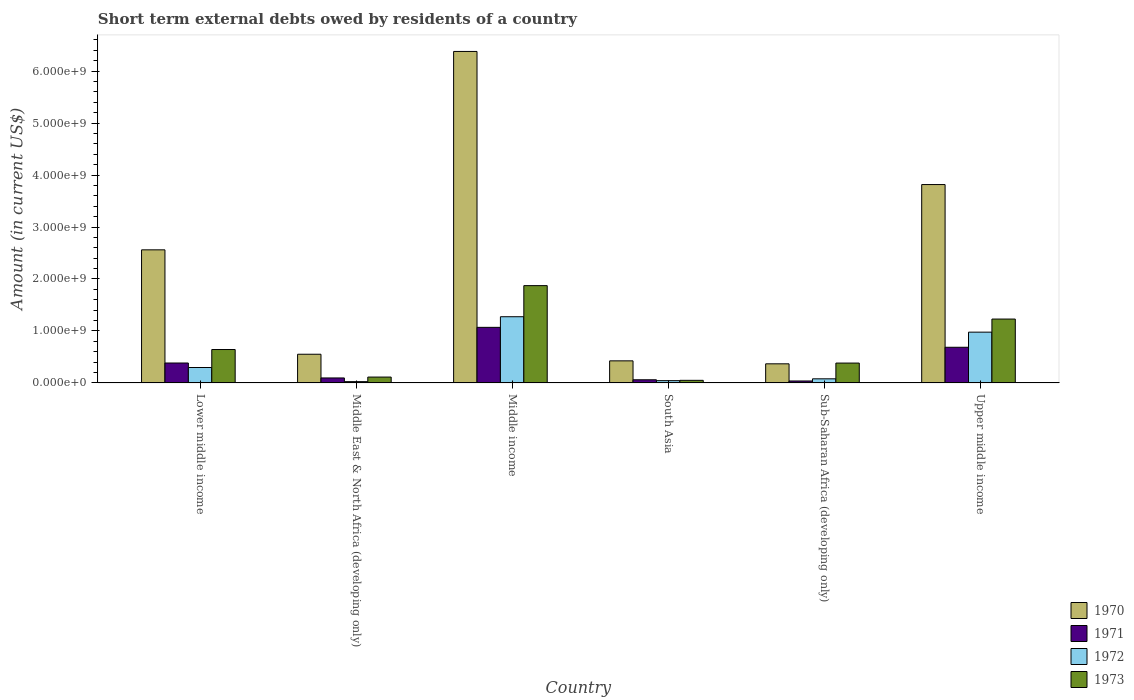How many groups of bars are there?
Your answer should be compact. 6. Are the number of bars per tick equal to the number of legend labels?
Offer a very short reply. Yes. Are the number of bars on each tick of the X-axis equal?
Make the answer very short. Yes. How many bars are there on the 5th tick from the left?
Make the answer very short. 4. What is the label of the 1st group of bars from the left?
Offer a terse response. Lower middle income. In how many cases, is the number of bars for a given country not equal to the number of legend labels?
Your response must be concise. 0. What is the amount of short-term external debts owed by residents in 1973 in Upper middle income?
Your answer should be compact. 1.23e+09. Across all countries, what is the maximum amount of short-term external debts owed by residents in 1970?
Offer a terse response. 6.38e+09. Across all countries, what is the minimum amount of short-term external debts owed by residents in 1970?
Give a very brief answer. 3.68e+08. In which country was the amount of short-term external debts owed by residents in 1973 maximum?
Provide a short and direct response. Middle income. What is the total amount of short-term external debts owed by residents in 1972 in the graph?
Provide a succinct answer. 2.70e+09. What is the difference between the amount of short-term external debts owed by residents in 1971 in Lower middle income and that in Upper middle income?
Ensure brevity in your answer.  -3.03e+08. What is the difference between the amount of short-term external debts owed by residents in 1972 in Middle income and the amount of short-term external debts owed by residents in 1973 in Upper middle income?
Ensure brevity in your answer.  4.48e+07. What is the average amount of short-term external debts owed by residents in 1970 per country?
Provide a succinct answer. 2.35e+09. What is the difference between the amount of short-term external debts owed by residents of/in 1973 and amount of short-term external debts owed by residents of/in 1971 in South Asia?
Your response must be concise. -1.10e+07. What is the ratio of the amount of short-term external debts owed by residents in 1970 in South Asia to that in Sub-Saharan Africa (developing only)?
Ensure brevity in your answer.  1.16. Is the amount of short-term external debts owed by residents in 1972 in Middle income less than that in Upper middle income?
Your answer should be very brief. No. Is the difference between the amount of short-term external debts owed by residents in 1973 in Lower middle income and Upper middle income greater than the difference between the amount of short-term external debts owed by residents in 1971 in Lower middle income and Upper middle income?
Give a very brief answer. No. What is the difference between the highest and the second highest amount of short-term external debts owed by residents in 1972?
Make the answer very short. 2.97e+08. What is the difference between the highest and the lowest amount of short-term external debts owed by residents in 1973?
Offer a terse response. 1.82e+09. In how many countries, is the amount of short-term external debts owed by residents in 1973 greater than the average amount of short-term external debts owed by residents in 1973 taken over all countries?
Provide a succinct answer. 2. Is the sum of the amount of short-term external debts owed by residents in 1971 in South Asia and Upper middle income greater than the maximum amount of short-term external debts owed by residents in 1970 across all countries?
Provide a short and direct response. No. Is it the case that in every country, the sum of the amount of short-term external debts owed by residents in 1972 and amount of short-term external debts owed by residents in 1971 is greater than the sum of amount of short-term external debts owed by residents in 1970 and amount of short-term external debts owed by residents in 1973?
Keep it short and to the point. No. What does the 2nd bar from the left in Middle East & North Africa (developing only) represents?
Your response must be concise. 1971. Is it the case that in every country, the sum of the amount of short-term external debts owed by residents in 1970 and amount of short-term external debts owed by residents in 1971 is greater than the amount of short-term external debts owed by residents in 1973?
Make the answer very short. Yes. Are all the bars in the graph horizontal?
Provide a short and direct response. No. How many countries are there in the graph?
Make the answer very short. 6. Are the values on the major ticks of Y-axis written in scientific E-notation?
Make the answer very short. Yes. Does the graph contain grids?
Offer a terse response. No. Where does the legend appear in the graph?
Keep it short and to the point. Bottom right. What is the title of the graph?
Keep it short and to the point. Short term external debts owed by residents of a country. Does "2015" appear as one of the legend labels in the graph?
Provide a short and direct response. No. What is the Amount (in current US$) in 1970 in Lower middle income?
Make the answer very short. 2.56e+09. What is the Amount (in current US$) in 1971 in Lower middle income?
Provide a succinct answer. 3.83e+08. What is the Amount (in current US$) in 1972 in Lower middle income?
Your response must be concise. 2.97e+08. What is the Amount (in current US$) in 1973 in Lower middle income?
Keep it short and to the point. 6.43e+08. What is the Amount (in current US$) of 1970 in Middle East & North Africa (developing only)?
Ensure brevity in your answer.  5.52e+08. What is the Amount (in current US$) in 1971 in Middle East & North Africa (developing only)?
Your response must be concise. 9.60e+07. What is the Amount (in current US$) in 1972 in Middle East & North Africa (developing only)?
Your answer should be very brief. 2.50e+07. What is the Amount (in current US$) of 1973 in Middle East & North Africa (developing only)?
Offer a very short reply. 1.13e+08. What is the Amount (in current US$) in 1970 in Middle income?
Provide a succinct answer. 6.38e+09. What is the Amount (in current US$) in 1971 in Middle income?
Provide a short and direct response. 1.07e+09. What is the Amount (in current US$) of 1972 in Middle income?
Ensure brevity in your answer.  1.27e+09. What is the Amount (in current US$) in 1973 in Middle income?
Ensure brevity in your answer.  1.87e+09. What is the Amount (in current US$) of 1970 in South Asia?
Ensure brevity in your answer.  4.25e+08. What is the Amount (in current US$) in 1971 in South Asia?
Your answer should be compact. 6.10e+07. What is the Amount (in current US$) in 1972 in South Asia?
Provide a short and direct response. 4.40e+07. What is the Amount (in current US$) in 1970 in Sub-Saharan Africa (developing only)?
Offer a very short reply. 3.68e+08. What is the Amount (in current US$) of 1971 in Sub-Saharan Africa (developing only)?
Keep it short and to the point. 3.78e+07. What is the Amount (in current US$) of 1972 in Sub-Saharan Africa (developing only)?
Provide a succinct answer. 7.93e+07. What is the Amount (in current US$) in 1973 in Sub-Saharan Africa (developing only)?
Offer a very short reply. 3.82e+08. What is the Amount (in current US$) of 1970 in Upper middle income?
Your answer should be very brief. 3.82e+09. What is the Amount (in current US$) of 1971 in Upper middle income?
Offer a terse response. 6.86e+08. What is the Amount (in current US$) of 1972 in Upper middle income?
Provide a short and direct response. 9.77e+08. What is the Amount (in current US$) of 1973 in Upper middle income?
Give a very brief answer. 1.23e+09. Across all countries, what is the maximum Amount (in current US$) in 1970?
Your response must be concise. 6.38e+09. Across all countries, what is the maximum Amount (in current US$) in 1971?
Keep it short and to the point. 1.07e+09. Across all countries, what is the maximum Amount (in current US$) of 1972?
Offer a very short reply. 1.27e+09. Across all countries, what is the maximum Amount (in current US$) in 1973?
Your response must be concise. 1.87e+09. Across all countries, what is the minimum Amount (in current US$) in 1970?
Offer a very short reply. 3.68e+08. Across all countries, what is the minimum Amount (in current US$) in 1971?
Your response must be concise. 3.78e+07. Across all countries, what is the minimum Amount (in current US$) in 1972?
Give a very brief answer. 2.50e+07. Across all countries, what is the minimum Amount (in current US$) in 1973?
Provide a succinct answer. 5.00e+07. What is the total Amount (in current US$) in 1970 in the graph?
Offer a terse response. 1.41e+1. What is the total Amount (in current US$) of 1971 in the graph?
Offer a very short reply. 2.33e+09. What is the total Amount (in current US$) of 1972 in the graph?
Provide a short and direct response. 2.70e+09. What is the total Amount (in current US$) in 1973 in the graph?
Make the answer very short. 4.29e+09. What is the difference between the Amount (in current US$) of 1970 in Lower middle income and that in Middle East & North Africa (developing only)?
Offer a terse response. 2.01e+09. What is the difference between the Amount (in current US$) in 1971 in Lower middle income and that in Middle East & North Africa (developing only)?
Offer a terse response. 2.87e+08. What is the difference between the Amount (in current US$) in 1972 in Lower middle income and that in Middle East & North Africa (developing only)?
Keep it short and to the point. 2.72e+08. What is the difference between the Amount (in current US$) in 1973 in Lower middle income and that in Middle East & North Africa (developing only)?
Offer a terse response. 5.30e+08. What is the difference between the Amount (in current US$) of 1970 in Lower middle income and that in Middle income?
Ensure brevity in your answer.  -3.82e+09. What is the difference between the Amount (in current US$) of 1971 in Lower middle income and that in Middle income?
Give a very brief answer. -6.86e+08. What is the difference between the Amount (in current US$) of 1972 in Lower middle income and that in Middle income?
Make the answer very short. -9.77e+08. What is the difference between the Amount (in current US$) in 1973 in Lower middle income and that in Middle income?
Offer a very short reply. -1.23e+09. What is the difference between the Amount (in current US$) in 1970 in Lower middle income and that in South Asia?
Your answer should be compact. 2.14e+09. What is the difference between the Amount (in current US$) in 1971 in Lower middle income and that in South Asia?
Give a very brief answer. 3.22e+08. What is the difference between the Amount (in current US$) in 1972 in Lower middle income and that in South Asia?
Give a very brief answer. 2.53e+08. What is the difference between the Amount (in current US$) of 1973 in Lower middle income and that in South Asia?
Keep it short and to the point. 5.93e+08. What is the difference between the Amount (in current US$) of 1970 in Lower middle income and that in Sub-Saharan Africa (developing only)?
Provide a succinct answer. 2.19e+09. What is the difference between the Amount (in current US$) in 1971 in Lower middle income and that in Sub-Saharan Africa (developing only)?
Ensure brevity in your answer.  3.46e+08. What is the difference between the Amount (in current US$) of 1972 in Lower middle income and that in Sub-Saharan Africa (developing only)?
Your answer should be very brief. 2.18e+08. What is the difference between the Amount (in current US$) in 1973 in Lower middle income and that in Sub-Saharan Africa (developing only)?
Give a very brief answer. 2.61e+08. What is the difference between the Amount (in current US$) in 1970 in Lower middle income and that in Upper middle income?
Make the answer very short. -1.26e+09. What is the difference between the Amount (in current US$) of 1971 in Lower middle income and that in Upper middle income?
Your answer should be compact. -3.03e+08. What is the difference between the Amount (in current US$) in 1972 in Lower middle income and that in Upper middle income?
Your response must be concise. -6.80e+08. What is the difference between the Amount (in current US$) in 1973 in Lower middle income and that in Upper middle income?
Offer a very short reply. -5.86e+08. What is the difference between the Amount (in current US$) of 1970 in Middle East & North Africa (developing only) and that in Middle income?
Provide a short and direct response. -5.83e+09. What is the difference between the Amount (in current US$) of 1971 in Middle East & North Africa (developing only) and that in Middle income?
Keep it short and to the point. -9.73e+08. What is the difference between the Amount (in current US$) of 1972 in Middle East & North Africa (developing only) and that in Middle income?
Your answer should be compact. -1.25e+09. What is the difference between the Amount (in current US$) in 1973 in Middle East & North Africa (developing only) and that in Middle income?
Offer a very short reply. -1.76e+09. What is the difference between the Amount (in current US$) in 1970 in Middle East & North Africa (developing only) and that in South Asia?
Offer a terse response. 1.27e+08. What is the difference between the Amount (in current US$) of 1971 in Middle East & North Africa (developing only) and that in South Asia?
Provide a short and direct response. 3.50e+07. What is the difference between the Amount (in current US$) of 1972 in Middle East & North Africa (developing only) and that in South Asia?
Offer a terse response. -1.90e+07. What is the difference between the Amount (in current US$) in 1973 in Middle East & North Africa (developing only) and that in South Asia?
Provide a succinct answer. 6.30e+07. What is the difference between the Amount (in current US$) in 1970 in Middle East & North Africa (developing only) and that in Sub-Saharan Africa (developing only)?
Offer a terse response. 1.84e+08. What is the difference between the Amount (in current US$) of 1971 in Middle East & North Africa (developing only) and that in Sub-Saharan Africa (developing only)?
Your answer should be very brief. 5.82e+07. What is the difference between the Amount (in current US$) in 1972 in Middle East & North Africa (developing only) and that in Sub-Saharan Africa (developing only)?
Your answer should be very brief. -5.43e+07. What is the difference between the Amount (in current US$) of 1973 in Middle East & North Africa (developing only) and that in Sub-Saharan Africa (developing only)?
Ensure brevity in your answer.  -2.69e+08. What is the difference between the Amount (in current US$) in 1970 in Middle East & North Africa (developing only) and that in Upper middle income?
Offer a very short reply. -3.26e+09. What is the difference between the Amount (in current US$) of 1971 in Middle East & North Africa (developing only) and that in Upper middle income?
Provide a short and direct response. -5.90e+08. What is the difference between the Amount (in current US$) of 1972 in Middle East & North Africa (developing only) and that in Upper middle income?
Offer a very short reply. -9.52e+08. What is the difference between the Amount (in current US$) in 1973 in Middle East & North Africa (developing only) and that in Upper middle income?
Ensure brevity in your answer.  -1.12e+09. What is the difference between the Amount (in current US$) in 1970 in Middle income and that in South Asia?
Your answer should be very brief. 5.95e+09. What is the difference between the Amount (in current US$) in 1971 in Middle income and that in South Asia?
Offer a terse response. 1.01e+09. What is the difference between the Amount (in current US$) of 1972 in Middle income and that in South Asia?
Offer a terse response. 1.23e+09. What is the difference between the Amount (in current US$) of 1973 in Middle income and that in South Asia?
Make the answer very short. 1.82e+09. What is the difference between the Amount (in current US$) of 1970 in Middle income and that in Sub-Saharan Africa (developing only)?
Keep it short and to the point. 6.01e+09. What is the difference between the Amount (in current US$) in 1971 in Middle income and that in Sub-Saharan Africa (developing only)?
Make the answer very short. 1.03e+09. What is the difference between the Amount (in current US$) in 1972 in Middle income and that in Sub-Saharan Africa (developing only)?
Offer a terse response. 1.19e+09. What is the difference between the Amount (in current US$) in 1973 in Middle income and that in Sub-Saharan Africa (developing only)?
Keep it short and to the point. 1.49e+09. What is the difference between the Amount (in current US$) of 1970 in Middle income and that in Upper middle income?
Provide a short and direct response. 2.56e+09. What is the difference between the Amount (in current US$) of 1971 in Middle income and that in Upper middle income?
Offer a terse response. 3.83e+08. What is the difference between the Amount (in current US$) in 1972 in Middle income and that in Upper middle income?
Your answer should be very brief. 2.97e+08. What is the difference between the Amount (in current US$) in 1973 in Middle income and that in Upper middle income?
Give a very brief answer. 6.43e+08. What is the difference between the Amount (in current US$) of 1970 in South Asia and that in Sub-Saharan Africa (developing only)?
Your answer should be very brief. 5.71e+07. What is the difference between the Amount (in current US$) of 1971 in South Asia and that in Sub-Saharan Africa (developing only)?
Provide a succinct answer. 2.32e+07. What is the difference between the Amount (in current US$) in 1972 in South Asia and that in Sub-Saharan Africa (developing only)?
Make the answer very short. -3.53e+07. What is the difference between the Amount (in current US$) of 1973 in South Asia and that in Sub-Saharan Africa (developing only)?
Your answer should be compact. -3.32e+08. What is the difference between the Amount (in current US$) of 1970 in South Asia and that in Upper middle income?
Your response must be concise. -3.39e+09. What is the difference between the Amount (in current US$) of 1971 in South Asia and that in Upper middle income?
Provide a short and direct response. -6.25e+08. What is the difference between the Amount (in current US$) of 1972 in South Asia and that in Upper middle income?
Keep it short and to the point. -9.33e+08. What is the difference between the Amount (in current US$) of 1973 in South Asia and that in Upper middle income?
Provide a short and direct response. -1.18e+09. What is the difference between the Amount (in current US$) of 1970 in Sub-Saharan Africa (developing only) and that in Upper middle income?
Provide a succinct answer. -3.45e+09. What is the difference between the Amount (in current US$) of 1971 in Sub-Saharan Africa (developing only) and that in Upper middle income?
Ensure brevity in your answer.  -6.48e+08. What is the difference between the Amount (in current US$) in 1972 in Sub-Saharan Africa (developing only) and that in Upper middle income?
Provide a short and direct response. -8.98e+08. What is the difference between the Amount (in current US$) of 1973 in Sub-Saharan Africa (developing only) and that in Upper middle income?
Your answer should be compact. -8.47e+08. What is the difference between the Amount (in current US$) of 1970 in Lower middle income and the Amount (in current US$) of 1971 in Middle East & North Africa (developing only)?
Provide a short and direct response. 2.46e+09. What is the difference between the Amount (in current US$) in 1970 in Lower middle income and the Amount (in current US$) in 1972 in Middle East & North Africa (developing only)?
Offer a very short reply. 2.54e+09. What is the difference between the Amount (in current US$) of 1970 in Lower middle income and the Amount (in current US$) of 1973 in Middle East & North Africa (developing only)?
Keep it short and to the point. 2.45e+09. What is the difference between the Amount (in current US$) of 1971 in Lower middle income and the Amount (in current US$) of 1972 in Middle East & North Africa (developing only)?
Your answer should be compact. 3.58e+08. What is the difference between the Amount (in current US$) in 1971 in Lower middle income and the Amount (in current US$) in 1973 in Middle East & North Africa (developing only)?
Offer a terse response. 2.70e+08. What is the difference between the Amount (in current US$) of 1972 in Lower middle income and the Amount (in current US$) of 1973 in Middle East & North Africa (developing only)?
Provide a short and direct response. 1.84e+08. What is the difference between the Amount (in current US$) of 1970 in Lower middle income and the Amount (in current US$) of 1971 in Middle income?
Offer a very short reply. 1.49e+09. What is the difference between the Amount (in current US$) in 1970 in Lower middle income and the Amount (in current US$) in 1972 in Middle income?
Offer a terse response. 1.29e+09. What is the difference between the Amount (in current US$) of 1970 in Lower middle income and the Amount (in current US$) of 1973 in Middle income?
Provide a short and direct response. 6.89e+08. What is the difference between the Amount (in current US$) of 1971 in Lower middle income and the Amount (in current US$) of 1972 in Middle income?
Make the answer very short. -8.91e+08. What is the difference between the Amount (in current US$) of 1971 in Lower middle income and the Amount (in current US$) of 1973 in Middle income?
Ensure brevity in your answer.  -1.49e+09. What is the difference between the Amount (in current US$) in 1972 in Lower middle income and the Amount (in current US$) in 1973 in Middle income?
Ensure brevity in your answer.  -1.58e+09. What is the difference between the Amount (in current US$) of 1970 in Lower middle income and the Amount (in current US$) of 1971 in South Asia?
Ensure brevity in your answer.  2.50e+09. What is the difference between the Amount (in current US$) of 1970 in Lower middle income and the Amount (in current US$) of 1972 in South Asia?
Provide a short and direct response. 2.52e+09. What is the difference between the Amount (in current US$) of 1970 in Lower middle income and the Amount (in current US$) of 1973 in South Asia?
Your answer should be very brief. 2.51e+09. What is the difference between the Amount (in current US$) in 1971 in Lower middle income and the Amount (in current US$) in 1972 in South Asia?
Make the answer very short. 3.39e+08. What is the difference between the Amount (in current US$) in 1971 in Lower middle income and the Amount (in current US$) in 1973 in South Asia?
Offer a terse response. 3.33e+08. What is the difference between the Amount (in current US$) of 1972 in Lower middle income and the Amount (in current US$) of 1973 in South Asia?
Offer a very short reply. 2.47e+08. What is the difference between the Amount (in current US$) in 1970 in Lower middle income and the Amount (in current US$) in 1971 in Sub-Saharan Africa (developing only)?
Your answer should be compact. 2.52e+09. What is the difference between the Amount (in current US$) of 1970 in Lower middle income and the Amount (in current US$) of 1972 in Sub-Saharan Africa (developing only)?
Your answer should be very brief. 2.48e+09. What is the difference between the Amount (in current US$) of 1970 in Lower middle income and the Amount (in current US$) of 1973 in Sub-Saharan Africa (developing only)?
Your answer should be very brief. 2.18e+09. What is the difference between the Amount (in current US$) of 1971 in Lower middle income and the Amount (in current US$) of 1972 in Sub-Saharan Africa (developing only)?
Offer a terse response. 3.04e+08. What is the difference between the Amount (in current US$) in 1971 in Lower middle income and the Amount (in current US$) in 1973 in Sub-Saharan Africa (developing only)?
Give a very brief answer. 1.02e+06. What is the difference between the Amount (in current US$) of 1972 in Lower middle income and the Amount (in current US$) of 1973 in Sub-Saharan Africa (developing only)?
Your response must be concise. -8.55e+07. What is the difference between the Amount (in current US$) of 1970 in Lower middle income and the Amount (in current US$) of 1971 in Upper middle income?
Ensure brevity in your answer.  1.87e+09. What is the difference between the Amount (in current US$) of 1970 in Lower middle income and the Amount (in current US$) of 1972 in Upper middle income?
Provide a succinct answer. 1.58e+09. What is the difference between the Amount (in current US$) of 1970 in Lower middle income and the Amount (in current US$) of 1973 in Upper middle income?
Ensure brevity in your answer.  1.33e+09. What is the difference between the Amount (in current US$) in 1971 in Lower middle income and the Amount (in current US$) in 1972 in Upper middle income?
Your answer should be compact. -5.94e+08. What is the difference between the Amount (in current US$) of 1971 in Lower middle income and the Amount (in current US$) of 1973 in Upper middle income?
Your answer should be compact. -8.46e+08. What is the difference between the Amount (in current US$) of 1972 in Lower middle income and the Amount (in current US$) of 1973 in Upper middle income?
Provide a short and direct response. -9.32e+08. What is the difference between the Amount (in current US$) of 1970 in Middle East & North Africa (developing only) and the Amount (in current US$) of 1971 in Middle income?
Make the answer very short. -5.17e+08. What is the difference between the Amount (in current US$) in 1970 in Middle East & North Africa (developing only) and the Amount (in current US$) in 1972 in Middle income?
Provide a succinct answer. -7.22e+08. What is the difference between the Amount (in current US$) of 1970 in Middle East & North Africa (developing only) and the Amount (in current US$) of 1973 in Middle income?
Your answer should be very brief. -1.32e+09. What is the difference between the Amount (in current US$) in 1971 in Middle East & North Africa (developing only) and the Amount (in current US$) in 1972 in Middle income?
Make the answer very short. -1.18e+09. What is the difference between the Amount (in current US$) in 1971 in Middle East & North Africa (developing only) and the Amount (in current US$) in 1973 in Middle income?
Make the answer very short. -1.78e+09. What is the difference between the Amount (in current US$) in 1972 in Middle East & North Africa (developing only) and the Amount (in current US$) in 1973 in Middle income?
Your response must be concise. -1.85e+09. What is the difference between the Amount (in current US$) in 1970 in Middle East & North Africa (developing only) and the Amount (in current US$) in 1971 in South Asia?
Keep it short and to the point. 4.91e+08. What is the difference between the Amount (in current US$) of 1970 in Middle East & North Africa (developing only) and the Amount (in current US$) of 1972 in South Asia?
Offer a terse response. 5.08e+08. What is the difference between the Amount (in current US$) of 1970 in Middle East & North Africa (developing only) and the Amount (in current US$) of 1973 in South Asia?
Offer a very short reply. 5.02e+08. What is the difference between the Amount (in current US$) in 1971 in Middle East & North Africa (developing only) and the Amount (in current US$) in 1972 in South Asia?
Provide a short and direct response. 5.20e+07. What is the difference between the Amount (in current US$) of 1971 in Middle East & North Africa (developing only) and the Amount (in current US$) of 1973 in South Asia?
Keep it short and to the point. 4.60e+07. What is the difference between the Amount (in current US$) in 1972 in Middle East & North Africa (developing only) and the Amount (in current US$) in 1973 in South Asia?
Your response must be concise. -2.50e+07. What is the difference between the Amount (in current US$) in 1970 in Middle East & North Africa (developing only) and the Amount (in current US$) in 1971 in Sub-Saharan Africa (developing only)?
Offer a terse response. 5.14e+08. What is the difference between the Amount (in current US$) of 1970 in Middle East & North Africa (developing only) and the Amount (in current US$) of 1972 in Sub-Saharan Africa (developing only)?
Offer a terse response. 4.73e+08. What is the difference between the Amount (in current US$) of 1970 in Middle East & North Africa (developing only) and the Amount (in current US$) of 1973 in Sub-Saharan Africa (developing only)?
Provide a short and direct response. 1.70e+08. What is the difference between the Amount (in current US$) of 1971 in Middle East & North Africa (developing only) and the Amount (in current US$) of 1972 in Sub-Saharan Africa (developing only)?
Keep it short and to the point. 1.67e+07. What is the difference between the Amount (in current US$) of 1971 in Middle East & North Africa (developing only) and the Amount (in current US$) of 1973 in Sub-Saharan Africa (developing only)?
Ensure brevity in your answer.  -2.86e+08. What is the difference between the Amount (in current US$) of 1972 in Middle East & North Africa (developing only) and the Amount (in current US$) of 1973 in Sub-Saharan Africa (developing only)?
Give a very brief answer. -3.57e+08. What is the difference between the Amount (in current US$) of 1970 in Middle East & North Africa (developing only) and the Amount (in current US$) of 1971 in Upper middle income?
Provide a succinct answer. -1.34e+08. What is the difference between the Amount (in current US$) in 1970 in Middle East & North Africa (developing only) and the Amount (in current US$) in 1972 in Upper middle income?
Keep it short and to the point. -4.25e+08. What is the difference between the Amount (in current US$) in 1970 in Middle East & North Africa (developing only) and the Amount (in current US$) in 1973 in Upper middle income?
Provide a short and direct response. -6.77e+08. What is the difference between the Amount (in current US$) in 1971 in Middle East & North Africa (developing only) and the Amount (in current US$) in 1972 in Upper middle income?
Make the answer very short. -8.81e+08. What is the difference between the Amount (in current US$) of 1971 in Middle East & North Africa (developing only) and the Amount (in current US$) of 1973 in Upper middle income?
Make the answer very short. -1.13e+09. What is the difference between the Amount (in current US$) in 1972 in Middle East & North Africa (developing only) and the Amount (in current US$) in 1973 in Upper middle income?
Give a very brief answer. -1.20e+09. What is the difference between the Amount (in current US$) of 1970 in Middle income and the Amount (in current US$) of 1971 in South Asia?
Offer a terse response. 6.32e+09. What is the difference between the Amount (in current US$) in 1970 in Middle income and the Amount (in current US$) in 1972 in South Asia?
Your response must be concise. 6.33e+09. What is the difference between the Amount (in current US$) in 1970 in Middle income and the Amount (in current US$) in 1973 in South Asia?
Give a very brief answer. 6.33e+09. What is the difference between the Amount (in current US$) of 1971 in Middle income and the Amount (in current US$) of 1972 in South Asia?
Offer a very short reply. 1.03e+09. What is the difference between the Amount (in current US$) in 1971 in Middle income and the Amount (in current US$) in 1973 in South Asia?
Provide a succinct answer. 1.02e+09. What is the difference between the Amount (in current US$) of 1972 in Middle income and the Amount (in current US$) of 1973 in South Asia?
Your answer should be very brief. 1.22e+09. What is the difference between the Amount (in current US$) of 1970 in Middle income and the Amount (in current US$) of 1971 in Sub-Saharan Africa (developing only)?
Offer a very short reply. 6.34e+09. What is the difference between the Amount (in current US$) in 1970 in Middle income and the Amount (in current US$) in 1972 in Sub-Saharan Africa (developing only)?
Give a very brief answer. 6.30e+09. What is the difference between the Amount (in current US$) of 1970 in Middle income and the Amount (in current US$) of 1973 in Sub-Saharan Africa (developing only)?
Ensure brevity in your answer.  6.00e+09. What is the difference between the Amount (in current US$) in 1971 in Middle income and the Amount (in current US$) in 1972 in Sub-Saharan Africa (developing only)?
Offer a very short reply. 9.90e+08. What is the difference between the Amount (in current US$) of 1971 in Middle income and the Amount (in current US$) of 1973 in Sub-Saharan Africa (developing only)?
Offer a very short reply. 6.87e+08. What is the difference between the Amount (in current US$) in 1972 in Middle income and the Amount (in current US$) in 1973 in Sub-Saharan Africa (developing only)?
Offer a terse response. 8.92e+08. What is the difference between the Amount (in current US$) in 1970 in Middle income and the Amount (in current US$) in 1971 in Upper middle income?
Give a very brief answer. 5.69e+09. What is the difference between the Amount (in current US$) in 1970 in Middle income and the Amount (in current US$) in 1972 in Upper middle income?
Provide a succinct answer. 5.40e+09. What is the difference between the Amount (in current US$) of 1970 in Middle income and the Amount (in current US$) of 1973 in Upper middle income?
Provide a short and direct response. 5.15e+09. What is the difference between the Amount (in current US$) in 1971 in Middle income and the Amount (in current US$) in 1972 in Upper middle income?
Provide a succinct answer. 9.23e+07. What is the difference between the Amount (in current US$) of 1971 in Middle income and the Amount (in current US$) of 1973 in Upper middle income?
Ensure brevity in your answer.  -1.60e+08. What is the difference between the Amount (in current US$) in 1972 in Middle income and the Amount (in current US$) in 1973 in Upper middle income?
Offer a very short reply. 4.48e+07. What is the difference between the Amount (in current US$) in 1970 in South Asia and the Amount (in current US$) in 1971 in Sub-Saharan Africa (developing only)?
Give a very brief answer. 3.87e+08. What is the difference between the Amount (in current US$) in 1970 in South Asia and the Amount (in current US$) in 1972 in Sub-Saharan Africa (developing only)?
Make the answer very short. 3.46e+08. What is the difference between the Amount (in current US$) in 1970 in South Asia and the Amount (in current US$) in 1973 in Sub-Saharan Africa (developing only)?
Make the answer very short. 4.27e+07. What is the difference between the Amount (in current US$) in 1971 in South Asia and the Amount (in current US$) in 1972 in Sub-Saharan Africa (developing only)?
Give a very brief answer. -1.83e+07. What is the difference between the Amount (in current US$) of 1971 in South Asia and the Amount (in current US$) of 1973 in Sub-Saharan Africa (developing only)?
Ensure brevity in your answer.  -3.21e+08. What is the difference between the Amount (in current US$) in 1972 in South Asia and the Amount (in current US$) in 1973 in Sub-Saharan Africa (developing only)?
Provide a short and direct response. -3.38e+08. What is the difference between the Amount (in current US$) of 1970 in South Asia and the Amount (in current US$) of 1971 in Upper middle income?
Provide a short and direct response. -2.61e+08. What is the difference between the Amount (in current US$) of 1970 in South Asia and the Amount (in current US$) of 1972 in Upper middle income?
Offer a very short reply. -5.52e+08. What is the difference between the Amount (in current US$) in 1970 in South Asia and the Amount (in current US$) in 1973 in Upper middle income?
Give a very brief answer. -8.04e+08. What is the difference between the Amount (in current US$) of 1971 in South Asia and the Amount (in current US$) of 1972 in Upper middle income?
Offer a very short reply. -9.16e+08. What is the difference between the Amount (in current US$) of 1971 in South Asia and the Amount (in current US$) of 1973 in Upper middle income?
Ensure brevity in your answer.  -1.17e+09. What is the difference between the Amount (in current US$) in 1972 in South Asia and the Amount (in current US$) in 1973 in Upper middle income?
Provide a succinct answer. -1.19e+09. What is the difference between the Amount (in current US$) in 1970 in Sub-Saharan Africa (developing only) and the Amount (in current US$) in 1971 in Upper middle income?
Your answer should be very brief. -3.18e+08. What is the difference between the Amount (in current US$) of 1970 in Sub-Saharan Africa (developing only) and the Amount (in current US$) of 1972 in Upper middle income?
Provide a succinct answer. -6.09e+08. What is the difference between the Amount (in current US$) of 1970 in Sub-Saharan Africa (developing only) and the Amount (in current US$) of 1973 in Upper middle income?
Offer a very short reply. -8.61e+08. What is the difference between the Amount (in current US$) of 1971 in Sub-Saharan Africa (developing only) and the Amount (in current US$) of 1972 in Upper middle income?
Provide a short and direct response. -9.39e+08. What is the difference between the Amount (in current US$) in 1971 in Sub-Saharan Africa (developing only) and the Amount (in current US$) in 1973 in Upper middle income?
Provide a succinct answer. -1.19e+09. What is the difference between the Amount (in current US$) of 1972 in Sub-Saharan Africa (developing only) and the Amount (in current US$) of 1973 in Upper middle income?
Your response must be concise. -1.15e+09. What is the average Amount (in current US$) of 1970 per country?
Your response must be concise. 2.35e+09. What is the average Amount (in current US$) in 1971 per country?
Make the answer very short. 3.89e+08. What is the average Amount (in current US$) of 1972 per country?
Keep it short and to the point. 4.49e+08. What is the average Amount (in current US$) in 1973 per country?
Keep it short and to the point. 7.15e+08. What is the difference between the Amount (in current US$) of 1970 and Amount (in current US$) of 1971 in Lower middle income?
Your answer should be very brief. 2.18e+09. What is the difference between the Amount (in current US$) of 1970 and Amount (in current US$) of 1972 in Lower middle income?
Provide a succinct answer. 2.26e+09. What is the difference between the Amount (in current US$) of 1970 and Amount (in current US$) of 1973 in Lower middle income?
Your response must be concise. 1.92e+09. What is the difference between the Amount (in current US$) in 1971 and Amount (in current US$) in 1972 in Lower middle income?
Make the answer very short. 8.65e+07. What is the difference between the Amount (in current US$) of 1971 and Amount (in current US$) of 1973 in Lower middle income?
Provide a short and direct response. -2.60e+08. What is the difference between the Amount (in current US$) of 1972 and Amount (in current US$) of 1973 in Lower middle income?
Your answer should be very brief. -3.46e+08. What is the difference between the Amount (in current US$) in 1970 and Amount (in current US$) in 1971 in Middle East & North Africa (developing only)?
Keep it short and to the point. 4.56e+08. What is the difference between the Amount (in current US$) in 1970 and Amount (in current US$) in 1972 in Middle East & North Africa (developing only)?
Keep it short and to the point. 5.27e+08. What is the difference between the Amount (in current US$) in 1970 and Amount (in current US$) in 1973 in Middle East & North Africa (developing only)?
Ensure brevity in your answer.  4.39e+08. What is the difference between the Amount (in current US$) in 1971 and Amount (in current US$) in 1972 in Middle East & North Africa (developing only)?
Your response must be concise. 7.10e+07. What is the difference between the Amount (in current US$) in 1971 and Amount (in current US$) in 1973 in Middle East & North Africa (developing only)?
Give a very brief answer. -1.70e+07. What is the difference between the Amount (in current US$) in 1972 and Amount (in current US$) in 1973 in Middle East & North Africa (developing only)?
Your answer should be very brief. -8.80e+07. What is the difference between the Amount (in current US$) of 1970 and Amount (in current US$) of 1971 in Middle income?
Your response must be concise. 5.31e+09. What is the difference between the Amount (in current US$) of 1970 and Amount (in current US$) of 1972 in Middle income?
Give a very brief answer. 5.10e+09. What is the difference between the Amount (in current US$) of 1970 and Amount (in current US$) of 1973 in Middle income?
Your answer should be compact. 4.51e+09. What is the difference between the Amount (in current US$) of 1971 and Amount (in current US$) of 1972 in Middle income?
Offer a terse response. -2.05e+08. What is the difference between the Amount (in current US$) of 1971 and Amount (in current US$) of 1973 in Middle income?
Make the answer very short. -8.03e+08. What is the difference between the Amount (in current US$) of 1972 and Amount (in current US$) of 1973 in Middle income?
Provide a succinct answer. -5.98e+08. What is the difference between the Amount (in current US$) in 1970 and Amount (in current US$) in 1971 in South Asia?
Keep it short and to the point. 3.64e+08. What is the difference between the Amount (in current US$) in 1970 and Amount (in current US$) in 1972 in South Asia?
Your answer should be compact. 3.81e+08. What is the difference between the Amount (in current US$) in 1970 and Amount (in current US$) in 1973 in South Asia?
Offer a terse response. 3.75e+08. What is the difference between the Amount (in current US$) in 1971 and Amount (in current US$) in 1972 in South Asia?
Your answer should be compact. 1.70e+07. What is the difference between the Amount (in current US$) of 1971 and Amount (in current US$) of 1973 in South Asia?
Your answer should be compact. 1.10e+07. What is the difference between the Amount (in current US$) in 1972 and Amount (in current US$) in 1973 in South Asia?
Ensure brevity in your answer.  -6.00e+06. What is the difference between the Amount (in current US$) of 1970 and Amount (in current US$) of 1971 in Sub-Saharan Africa (developing only)?
Keep it short and to the point. 3.30e+08. What is the difference between the Amount (in current US$) of 1970 and Amount (in current US$) of 1972 in Sub-Saharan Africa (developing only)?
Keep it short and to the point. 2.89e+08. What is the difference between the Amount (in current US$) in 1970 and Amount (in current US$) in 1973 in Sub-Saharan Africa (developing only)?
Offer a terse response. -1.44e+07. What is the difference between the Amount (in current US$) in 1971 and Amount (in current US$) in 1972 in Sub-Saharan Africa (developing only)?
Offer a terse response. -4.15e+07. What is the difference between the Amount (in current US$) in 1971 and Amount (in current US$) in 1973 in Sub-Saharan Africa (developing only)?
Offer a very short reply. -3.45e+08. What is the difference between the Amount (in current US$) of 1972 and Amount (in current US$) of 1973 in Sub-Saharan Africa (developing only)?
Keep it short and to the point. -3.03e+08. What is the difference between the Amount (in current US$) of 1970 and Amount (in current US$) of 1971 in Upper middle income?
Offer a terse response. 3.13e+09. What is the difference between the Amount (in current US$) in 1970 and Amount (in current US$) in 1972 in Upper middle income?
Your answer should be compact. 2.84e+09. What is the difference between the Amount (in current US$) in 1970 and Amount (in current US$) in 1973 in Upper middle income?
Offer a very short reply. 2.59e+09. What is the difference between the Amount (in current US$) of 1971 and Amount (in current US$) of 1972 in Upper middle income?
Provide a short and direct response. -2.91e+08. What is the difference between the Amount (in current US$) of 1971 and Amount (in current US$) of 1973 in Upper middle income?
Keep it short and to the point. -5.43e+08. What is the difference between the Amount (in current US$) of 1972 and Amount (in current US$) of 1973 in Upper middle income?
Provide a succinct answer. -2.52e+08. What is the ratio of the Amount (in current US$) of 1970 in Lower middle income to that in Middle East & North Africa (developing only)?
Provide a short and direct response. 4.64. What is the ratio of the Amount (in current US$) in 1971 in Lower middle income to that in Middle East & North Africa (developing only)?
Your answer should be compact. 3.99. What is the ratio of the Amount (in current US$) in 1972 in Lower middle income to that in Middle East & North Africa (developing only)?
Offer a very short reply. 11.87. What is the ratio of the Amount (in current US$) of 1973 in Lower middle income to that in Middle East & North Africa (developing only)?
Give a very brief answer. 5.69. What is the ratio of the Amount (in current US$) in 1970 in Lower middle income to that in Middle income?
Ensure brevity in your answer.  0.4. What is the ratio of the Amount (in current US$) in 1971 in Lower middle income to that in Middle income?
Provide a short and direct response. 0.36. What is the ratio of the Amount (in current US$) in 1972 in Lower middle income to that in Middle income?
Offer a terse response. 0.23. What is the ratio of the Amount (in current US$) in 1973 in Lower middle income to that in Middle income?
Make the answer very short. 0.34. What is the ratio of the Amount (in current US$) in 1970 in Lower middle income to that in South Asia?
Offer a very short reply. 6.03. What is the ratio of the Amount (in current US$) in 1971 in Lower middle income to that in South Asia?
Ensure brevity in your answer.  6.28. What is the ratio of the Amount (in current US$) in 1972 in Lower middle income to that in South Asia?
Provide a succinct answer. 6.75. What is the ratio of the Amount (in current US$) in 1973 in Lower middle income to that in South Asia?
Your answer should be compact. 12.86. What is the ratio of the Amount (in current US$) in 1970 in Lower middle income to that in Sub-Saharan Africa (developing only)?
Make the answer very short. 6.96. What is the ratio of the Amount (in current US$) of 1971 in Lower middle income to that in Sub-Saharan Africa (developing only)?
Give a very brief answer. 10.14. What is the ratio of the Amount (in current US$) in 1972 in Lower middle income to that in Sub-Saharan Africa (developing only)?
Your response must be concise. 3.74. What is the ratio of the Amount (in current US$) in 1973 in Lower middle income to that in Sub-Saharan Africa (developing only)?
Offer a very short reply. 1.68. What is the ratio of the Amount (in current US$) of 1970 in Lower middle income to that in Upper middle income?
Your response must be concise. 0.67. What is the ratio of the Amount (in current US$) of 1971 in Lower middle income to that in Upper middle income?
Your response must be concise. 0.56. What is the ratio of the Amount (in current US$) of 1972 in Lower middle income to that in Upper middle income?
Keep it short and to the point. 0.3. What is the ratio of the Amount (in current US$) in 1973 in Lower middle income to that in Upper middle income?
Give a very brief answer. 0.52. What is the ratio of the Amount (in current US$) in 1970 in Middle East & North Africa (developing only) to that in Middle income?
Give a very brief answer. 0.09. What is the ratio of the Amount (in current US$) in 1971 in Middle East & North Africa (developing only) to that in Middle income?
Offer a very short reply. 0.09. What is the ratio of the Amount (in current US$) in 1972 in Middle East & North Africa (developing only) to that in Middle income?
Provide a short and direct response. 0.02. What is the ratio of the Amount (in current US$) in 1973 in Middle East & North Africa (developing only) to that in Middle income?
Offer a terse response. 0.06. What is the ratio of the Amount (in current US$) in 1970 in Middle East & North Africa (developing only) to that in South Asia?
Your answer should be compact. 1.3. What is the ratio of the Amount (in current US$) of 1971 in Middle East & North Africa (developing only) to that in South Asia?
Your answer should be compact. 1.57. What is the ratio of the Amount (in current US$) in 1972 in Middle East & North Africa (developing only) to that in South Asia?
Provide a short and direct response. 0.57. What is the ratio of the Amount (in current US$) of 1973 in Middle East & North Africa (developing only) to that in South Asia?
Offer a very short reply. 2.26. What is the ratio of the Amount (in current US$) in 1970 in Middle East & North Africa (developing only) to that in Sub-Saharan Africa (developing only)?
Offer a very short reply. 1.5. What is the ratio of the Amount (in current US$) of 1971 in Middle East & North Africa (developing only) to that in Sub-Saharan Africa (developing only)?
Provide a short and direct response. 2.54. What is the ratio of the Amount (in current US$) in 1972 in Middle East & North Africa (developing only) to that in Sub-Saharan Africa (developing only)?
Keep it short and to the point. 0.32. What is the ratio of the Amount (in current US$) in 1973 in Middle East & North Africa (developing only) to that in Sub-Saharan Africa (developing only)?
Keep it short and to the point. 0.3. What is the ratio of the Amount (in current US$) in 1970 in Middle East & North Africa (developing only) to that in Upper middle income?
Provide a succinct answer. 0.14. What is the ratio of the Amount (in current US$) in 1971 in Middle East & North Africa (developing only) to that in Upper middle income?
Keep it short and to the point. 0.14. What is the ratio of the Amount (in current US$) in 1972 in Middle East & North Africa (developing only) to that in Upper middle income?
Ensure brevity in your answer.  0.03. What is the ratio of the Amount (in current US$) of 1973 in Middle East & North Africa (developing only) to that in Upper middle income?
Make the answer very short. 0.09. What is the ratio of the Amount (in current US$) in 1970 in Middle income to that in South Asia?
Your response must be concise. 15.01. What is the ratio of the Amount (in current US$) of 1971 in Middle income to that in South Asia?
Ensure brevity in your answer.  17.53. What is the ratio of the Amount (in current US$) of 1972 in Middle income to that in South Asia?
Give a very brief answer. 28.95. What is the ratio of the Amount (in current US$) in 1973 in Middle income to that in South Asia?
Ensure brevity in your answer.  37.44. What is the ratio of the Amount (in current US$) in 1970 in Middle income to that in Sub-Saharan Africa (developing only)?
Your answer should be compact. 17.34. What is the ratio of the Amount (in current US$) of 1971 in Middle income to that in Sub-Saharan Africa (developing only)?
Give a very brief answer. 28.29. What is the ratio of the Amount (in current US$) in 1972 in Middle income to that in Sub-Saharan Africa (developing only)?
Your response must be concise. 16.06. What is the ratio of the Amount (in current US$) in 1973 in Middle income to that in Sub-Saharan Africa (developing only)?
Provide a succinct answer. 4.9. What is the ratio of the Amount (in current US$) of 1970 in Middle income to that in Upper middle income?
Ensure brevity in your answer.  1.67. What is the ratio of the Amount (in current US$) in 1971 in Middle income to that in Upper middle income?
Your answer should be compact. 1.56. What is the ratio of the Amount (in current US$) in 1972 in Middle income to that in Upper middle income?
Provide a short and direct response. 1.3. What is the ratio of the Amount (in current US$) in 1973 in Middle income to that in Upper middle income?
Your response must be concise. 1.52. What is the ratio of the Amount (in current US$) in 1970 in South Asia to that in Sub-Saharan Africa (developing only)?
Give a very brief answer. 1.16. What is the ratio of the Amount (in current US$) in 1971 in South Asia to that in Sub-Saharan Africa (developing only)?
Your response must be concise. 1.61. What is the ratio of the Amount (in current US$) of 1972 in South Asia to that in Sub-Saharan Africa (developing only)?
Make the answer very short. 0.55. What is the ratio of the Amount (in current US$) in 1973 in South Asia to that in Sub-Saharan Africa (developing only)?
Make the answer very short. 0.13. What is the ratio of the Amount (in current US$) of 1970 in South Asia to that in Upper middle income?
Your answer should be compact. 0.11. What is the ratio of the Amount (in current US$) of 1971 in South Asia to that in Upper middle income?
Your response must be concise. 0.09. What is the ratio of the Amount (in current US$) of 1972 in South Asia to that in Upper middle income?
Your response must be concise. 0.04. What is the ratio of the Amount (in current US$) in 1973 in South Asia to that in Upper middle income?
Give a very brief answer. 0.04. What is the ratio of the Amount (in current US$) in 1970 in Sub-Saharan Africa (developing only) to that in Upper middle income?
Give a very brief answer. 0.1. What is the ratio of the Amount (in current US$) of 1971 in Sub-Saharan Africa (developing only) to that in Upper middle income?
Keep it short and to the point. 0.06. What is the ratio of the Amount (in current US$) of 1972 in Sub-Saharan Africa (developing only) to that in Upper middle income?
Your answer should be compact. 0.08. What is the ratio of the Amount (in current US$) in 1973 in Sub-Saharan Africa (developing only) to that in Upper middle income?
Provide a short and direct response. 0.31. What is the difference between the highest and the second highest Amount (in current US$) of 1970?
Make the answer very short. 2.56e+09. What is the difference between the highest and the second highest Amount (in current US$) of 1971?
Offer a very short reply. 3.83e+08. What is the difference between the highest and the second highest Amount (in current US$) in 1972?
Offer a very short reply. 2.97e+08. What is the difference between the highest and the second highest Amount (in current US$) of 1973?
Your answer should be very brief. 6.43e+08. What is the difference between the highest and the lowest Amount (in current US$) of 1970?
Ensure brevity in your answer.  6.01e+09. What is the difference between the highest and the lowest Amount (in current US$) in 1971?
Your response must be concise. 1.03e+09. What is the difference between the highest and the lowest Amount (in current US$) of 1972?
Give a very brief answer. 1.25e+09. What is the difference between the highest and the lowest Amount (in current US$) in 1973?
Give a very brief answer. 1.82e+09. 